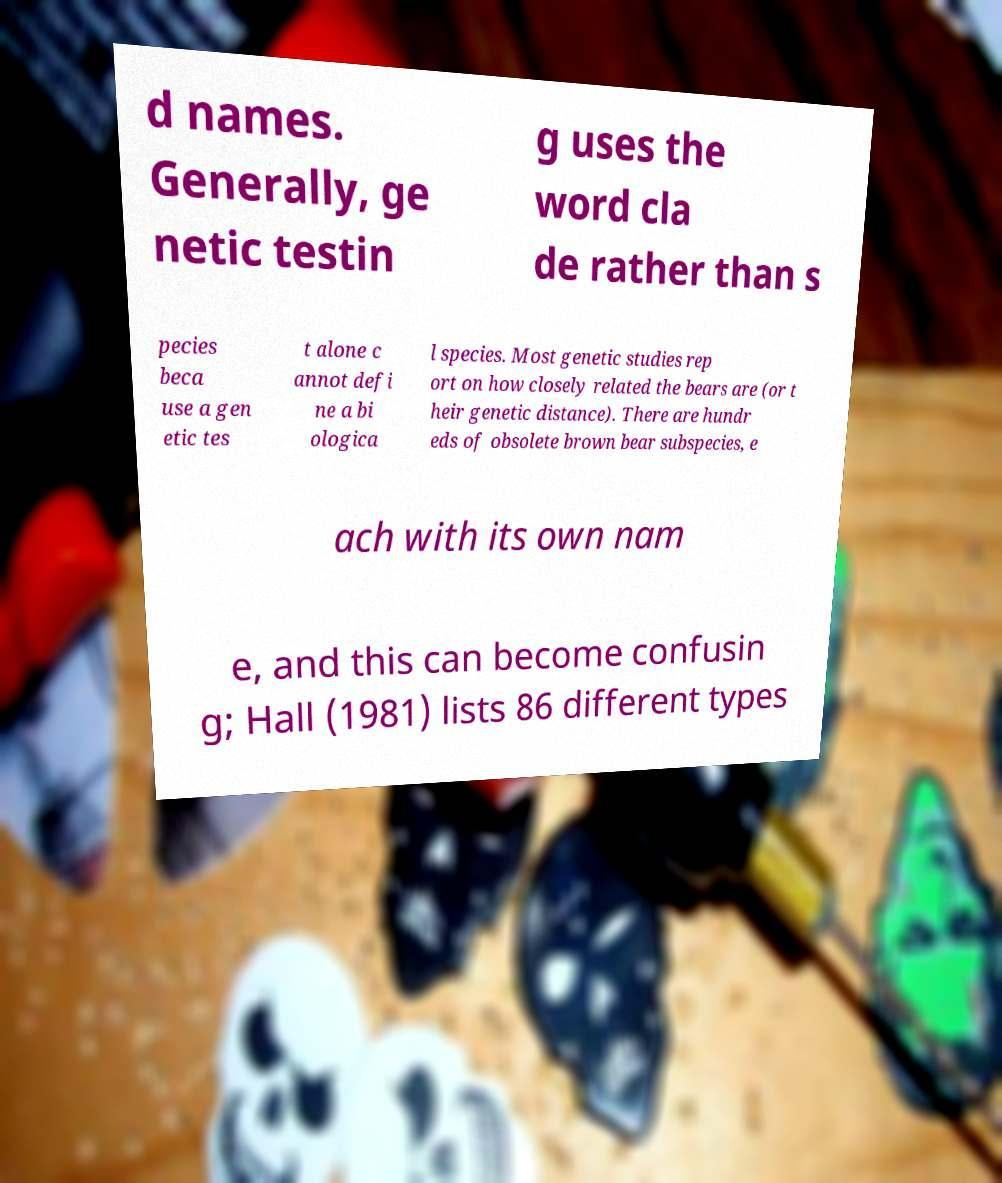There's text embedded in this image that I need extracted. Can you transcribe it verbatim? d names. Generally, ge netic testin g uses the word cla de rather than s pecies beca use a gen etic tes t alone c annot defi ne a bi ologica l species. Most genetic studies rep ort on how closely related the bears are (or t heir genetic distance). There are hundr eds of obsolete brown bear subspecies, e ach with its own nam e, and this can become confusin g; Hall (1981) lists 86 different types 